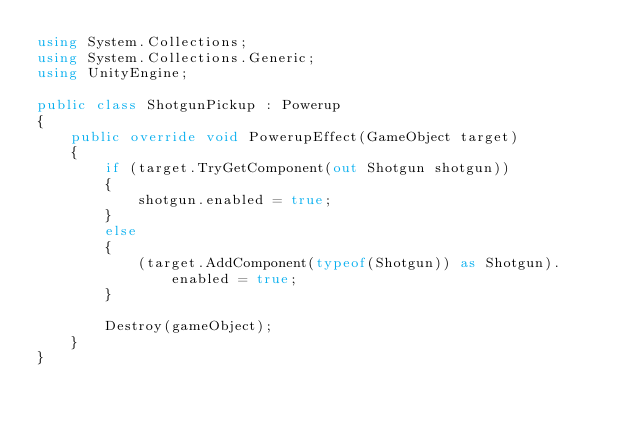<code> <loc_0><loc_0><loc_500><loc_500><_C#_>using System.Collections;
using System.Collections.Generic;
using UnityEngine;

public class ShotgunPickup : Powerup
{
    public override void PowerupEffect(GameObject target)
    {
        if (target.TryGetComponent(out Shotgun shotgun))
        {
            shotgun.enabled = true;
        }
        else
        {
            (target.AddComponent(typeof(Shotgun)) as Shotgun).enabled = true;
        }

        Destroy(gameObject);
    }
}
</code> 